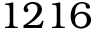Convert formula to latex. <formula><loc_0><loc_0><loc_500><loc_500>1 2 1 6</formula> 